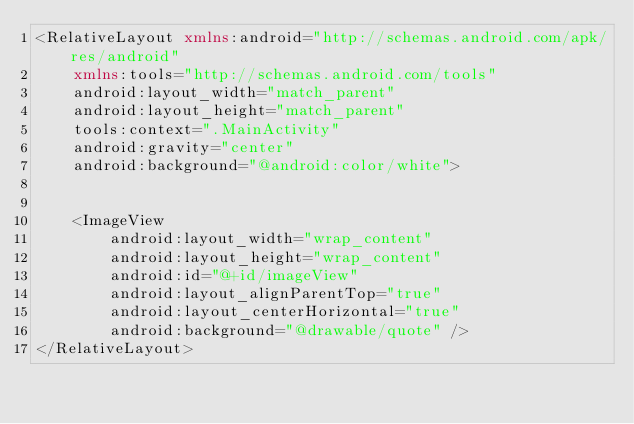<code> <loc_0><loc_0><loc_500><loc_500><_XML_><RelativeLayout xmlns:android="http://schemas.android.com/apk/res/android"
    xmlns:tools="http://schemas.android.com/tools"
    android:layout_width="match_parent"
    android:layout_height="match_parent"
    tools:context=".MainActivity"
    android:gravity="center"
    android:background="@android:color/white">


    <ImageView
        android:layout_width="wrap_content"
        android:layout_height="wrap_content"
        android:id="@+id/imageView"
        android:layout_alignParentTop="true"
        android:layout_centerHorizontal="true"
        android:background="@drawable/quote" />
</RelativeLayout></code> 